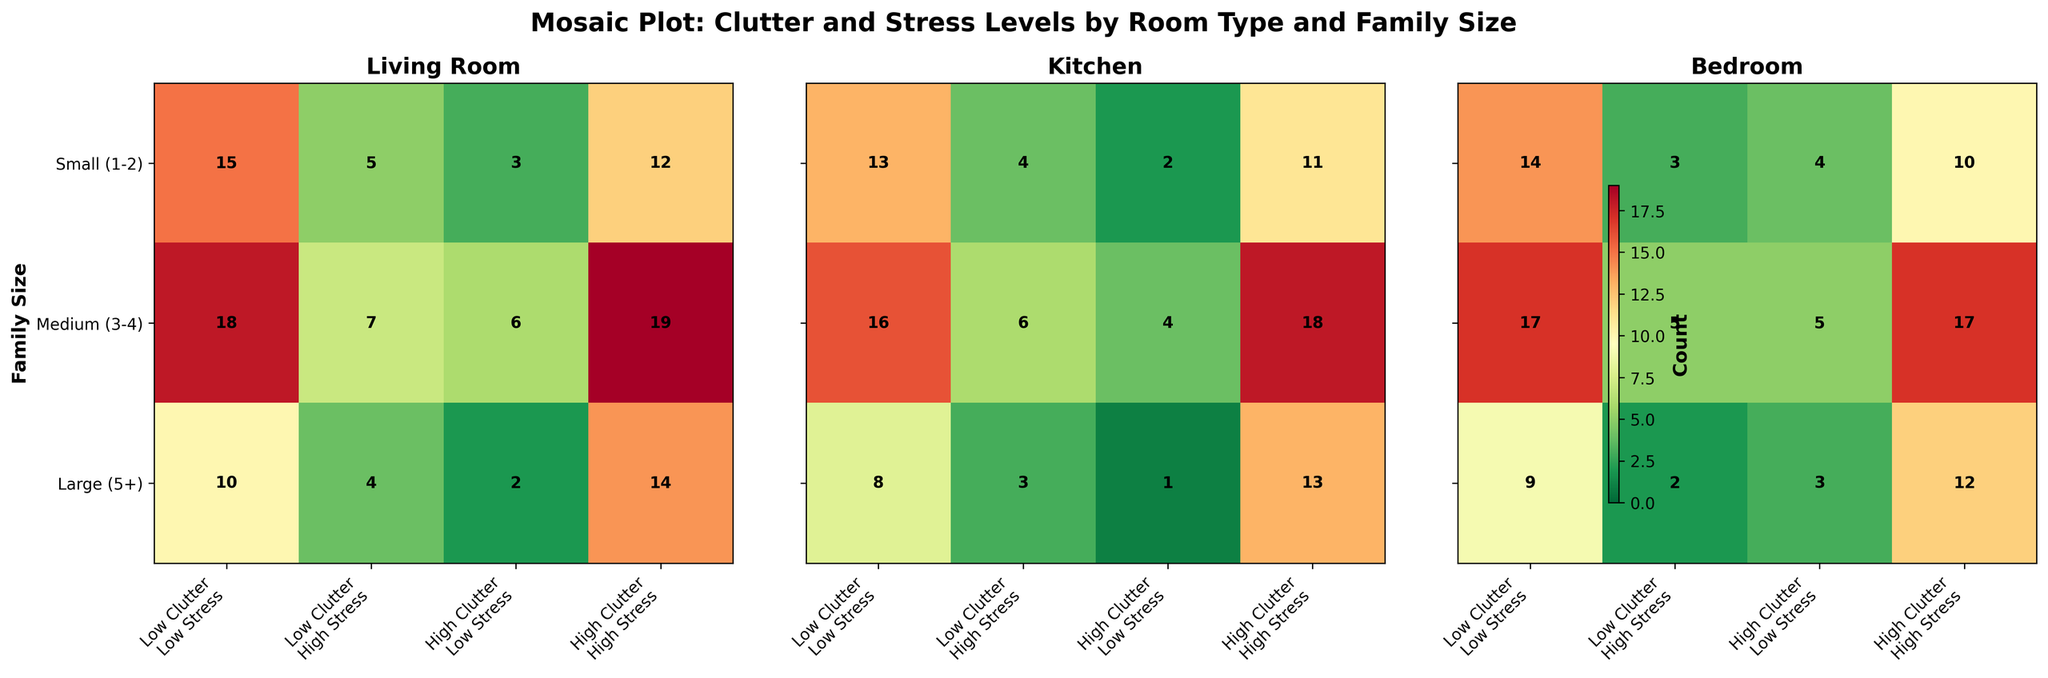What is the title of the mosaic plot? The title of the mosaic plot is at the top of the figure.
Answer: Mosaic Plot: Clutter and Stress Levels by Room Type and Family Size How many room types are compared in the plot? The plot contains three subplots, each representing a different room type.
Answer: 3 Which family size in the living room has the highest number of high clutter and high stress counts? To answer this, look at the living room subplot and the column for high clutter, high stress. The row with the largest number is the family size with the highest count.
Answer: Medium (3-4) For medium-sized families, how does the clutter-stress distribution in kitchens compare to bedrooms? Compare the counts in the kitchen subplot versus the bedroom subplot for medium-sized families across all clutter-stress categories.
Answer: More high clutter, high stress counts in the kitchen Which room type and family size combination has the lowest clutter and stress levels? Look for the smallest count in the 'Low Clutter, Low Stress' category across all room types and family sizes.
Answer: Large family in the kitchen Is there any family size that consistently shows high clutter, high stress across all room types? Check the counts in the 'High Clutter, High Stress' category for each room type for consistency in one family size.
Answer: Medium (3-4) Which room type has the highest variance in clutter and stress levels for small families? Compare the range of counts for small families across all stress and clutter combinations in each room type's subplot.
Answer: Living Room In the bedrooms, which clutter and stress combination shows the greatest difference in counts between small and large families? Calculate the difference in counts for each clutter-stress combination between small and large families within the bedroom subplot and identify the combination with the greatest difference.
Answer: High Clutter, High Stress What is the total count of low clutter, low stress instances across all room types? Add up the counts for the 'Low Clutter, Low Stress' category in each room type subplot.
Answer: 94 